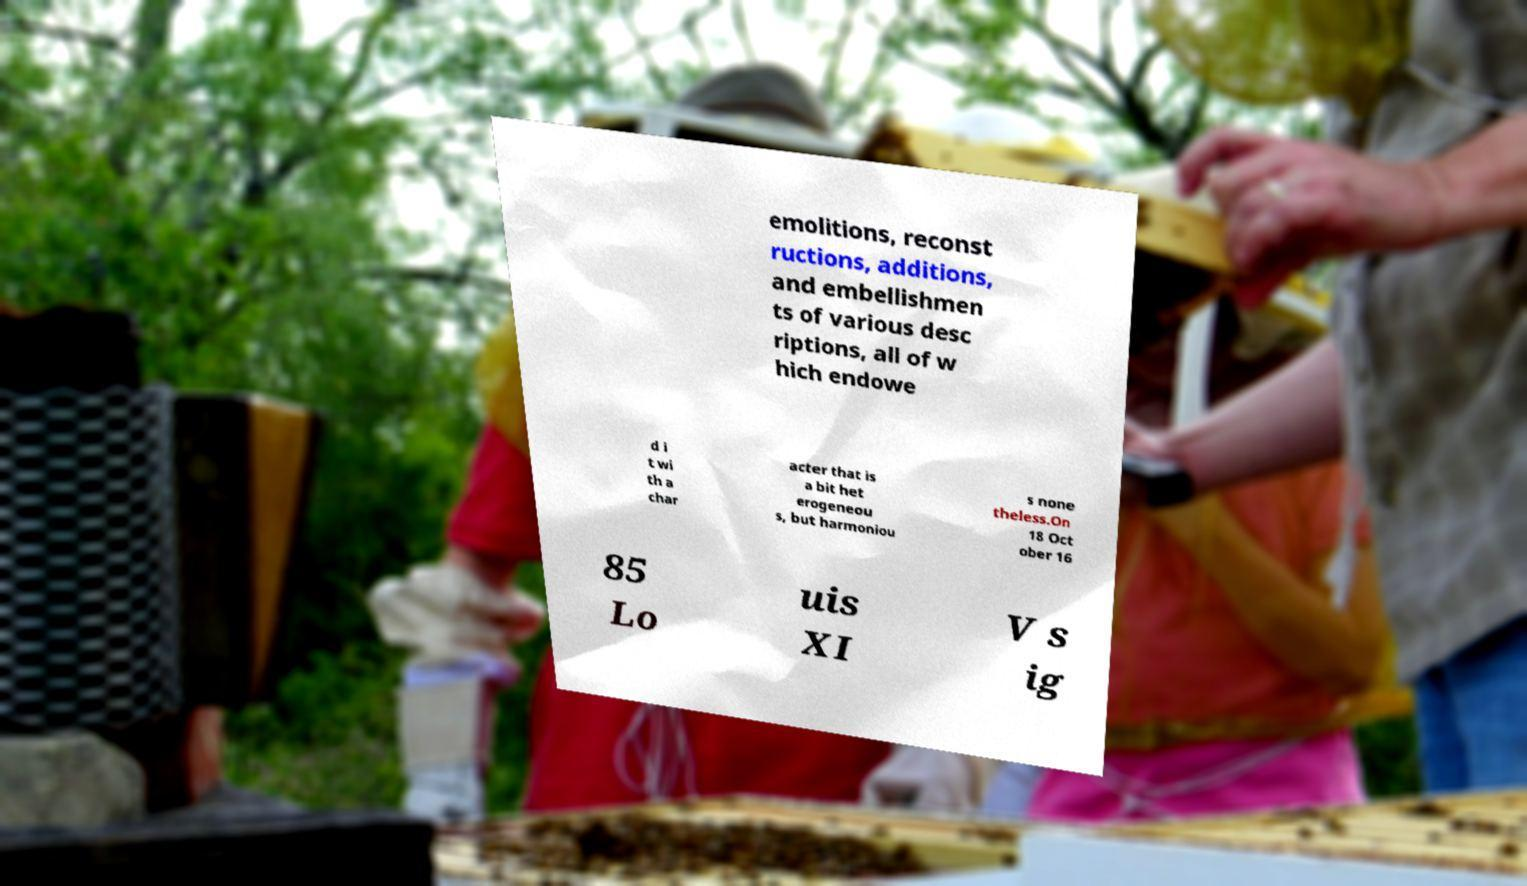What messages or text are displayed in this image? I need them in a readable, typed format. emolitions, reconst ructions, additions, and embellishmen ts of various desc riptions, all of w hich endowe d i t wi th a char acter that is a bit het erogeneou s, but harmoniou s none theless.On 18 Oct ober 16 85 Lo uis XI V s ig 